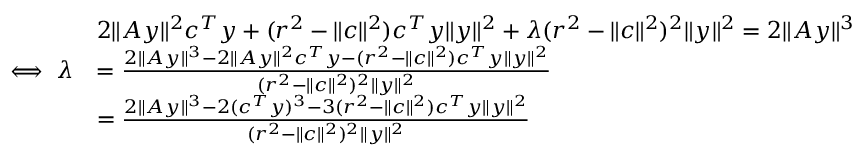<formula> <loc_0><loc_0><loc_500><loc_500>\begin{array} { r l } & { 2 \| A y \| ^ { 2 } c ^ { T } y + ( r ^ { 2 } - \| c \| ^ { 2 } ) c ^ { T } y \| y \| ^ { 2 } + \lambda ( r ^ { 2 } - \| c \| ^ { 2 } ) ^ { 2 } \| y \| ^ { 2 } = 2 \| A y \| ^ { 3 } } \\ { \iff \lambda } & { = \frac { 2 \| A y \| ^ { 3 } - 2 \| A y \| ^ { 2 } c ^ { T } y - ( r ^ { 2 } - \| c \| ^ { 2 } ) c ^ { T } y \| y \| ^ { 2 } } { ( r ^ { 2 } - \| c \| ^ { 2 } ) ^ { 2 } \| y \| ^ { 2 } } } \\ & { = \frac { 2 \| A y \| ^ { 3 } - 2 ( c ^ { T } y ) ^ { 3 } - 3 ( r ^ { 2 } - \| c \| ^ { 2 } ) c ^ { T } y \| y \| ^ { 2 } } { ( r ^ { 2 } - \| c \| ^ { 2 } ) ^ { 2 } \| y \| ^ { 2 } } } \end{array}</formula> 